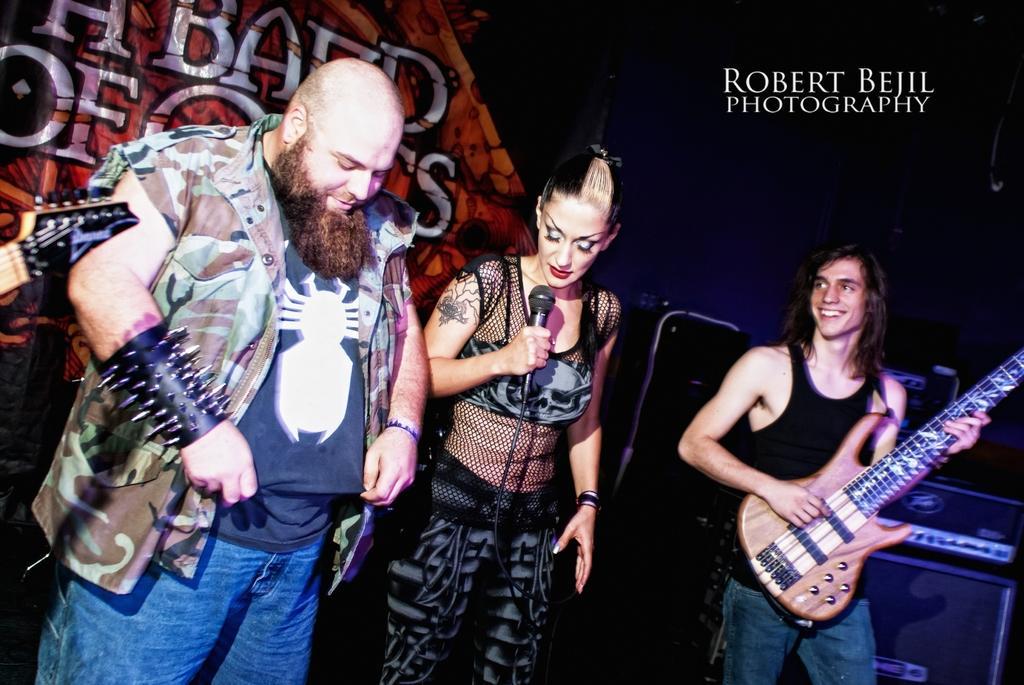Can you describe this image briefly? In this image i can see 2 men and a woman standing on the stage, the man on the right side is holding a guitar and the woman is holding a microphone. In the background i can see a banner, a speaker and a musical system. 